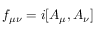Convert formula to latex. <formula><loc_0><loc_0><loc_500><loc_500>f _ { \mu \nu } = i [ A _ { \mu } , A _ { \nu } ]</formula> 